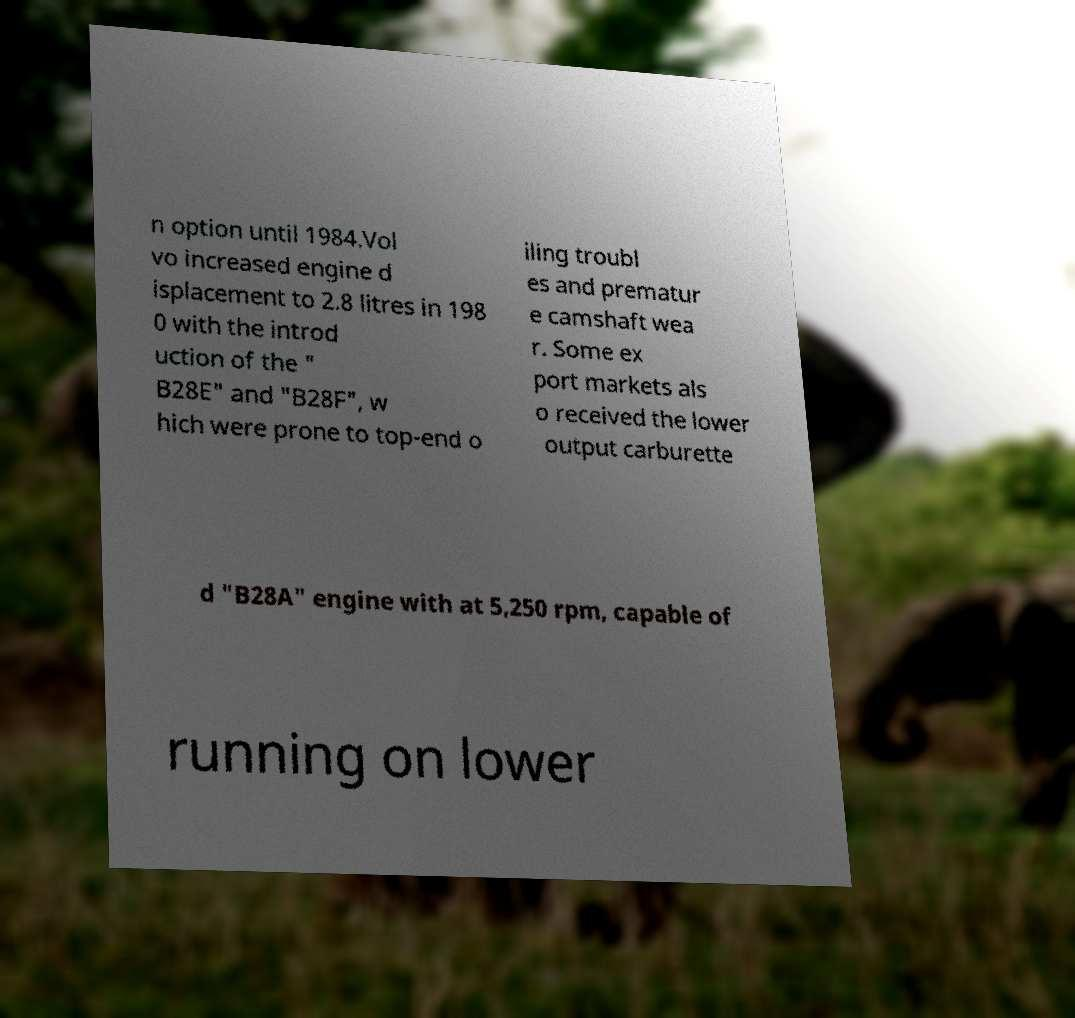Could you assist in decoding the text presented in this image and type it out clearly? n option until 1984.Vol vo increased engine d isplacement to 2.8 litres in 198 0 with the introd uction of the " B28E" and "B28F", w hich were prone to top-end o iling troubl es and prematur e camshaft wea r. Some ex port markets als o received the lower output carburette d "B28A" engine with at 5,250 rpm, capable of running on lower 